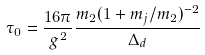<formula> <loc_0><loc_0><loc_500><loc_500>\tau _ { 0 } = \frac { 1 6 \pi } { g ^ { 2 } } \frac { m _ { 2 } ( 1 + m _ { j } / m _ { 2 } ) ^ { - 2 } } { \Delta _ { d } }</formula> 